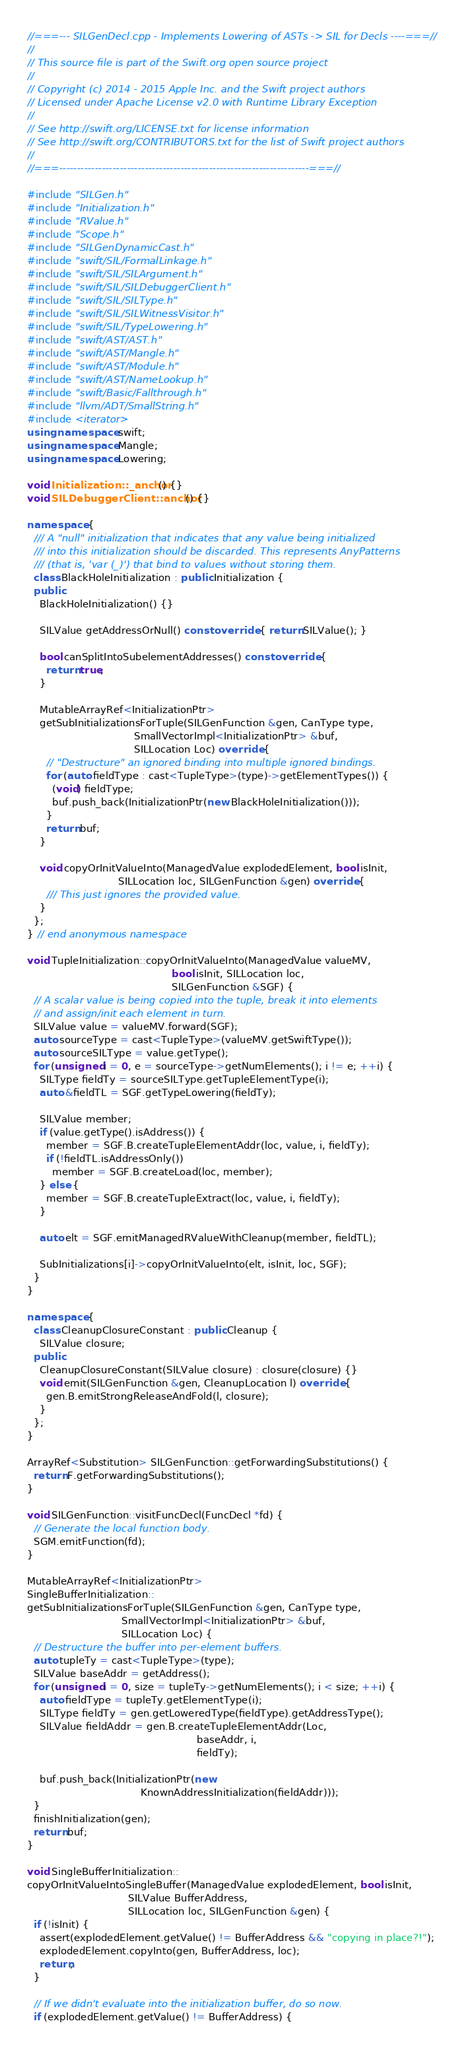<code> <loc_0><loc_0><loc_500><loc_500><_C++_>//===--- SILGenDecl.cpp - Implements Lowering of ASTs -> SIL for Decls ----===//
//
// This source file is part of the Swift.org open source project
//
// Copyright (c) 2014 - 2015 Apple Inc. and the Swift project authors
// Licensed under Apache License v2.0 with Runtime Library Exception
//
// See http://swift.org/LICENSE.txt for license information
// See http://swift.org/CONTRIBUTORS.txt for the list of Swift project authors
//
//===----------------------------------------------------------------------===//

#include "SILGen.h"
#include "Initialization.h"
#include "RValue.h"
#include "Scope.h"
#include "SILGenDynamicCast.h"
#include "swift/SIL/FormalLinkage.h"
#include "swift/SIL/SILArgument.h"
#include "swift/SIL/SILDebuggerClient.h"
#include "swift/SIL/SILType.h"
#include "swift/SIL/SILWitnessVisitor.h"
#include "swift/SIL/TypeLowering.h"
#include "swift/AST/AST.h"
#include "swift/AST/Mangle.h"
#include "swift/AST/Module.h"
#include "swift/AST/NameLookup.h"
#include "swift/Basic/Fallthrough.h"
#include "llvm/ADT/SmallString.h"
#include <iterator>
using namespace swift;
using namespace Mangle;
using namespace Lowering;

void Initialization::_anchor() {}
void SILDebuggerClient::anchor() {}

namespace {
  /// A "null" initialization that indicates that any value being initialized
  /// into this initialization should be discarded. This represents AnyPatterns
  /// (that is, 'var (_)') that bind to values without storing them.
  class BlackHoleInitialization : public Initialization {
  public:
    BlackHoleInitialization() {}

    SILValue getAddressOrNull() const override { return SILValue(); }

    bool canSplitIntoSubelementAddresses() const override {
      return true;
    }
    
    MutableArrayRef<InitializationPtr>
    getSubInitializationsForTuple(SILGenFunction &gen, CanType type,
                                  SmallVectorImpl<InitializationPtr> &buf,
                                  SILLocation Loc) override {
      // "Destructure" an ignored binding into multiple ignored bindings.
      for (auto fieldType : cast<TupleType>(type)->getElementTypes()) {
        (void) fieldType;
        buf.push_back(InitializationPtr(new BlackHoleInitialization()));
      }
      return buf;
    }

    void copyOrInitValueInto(ManagedValue explodedElement, bool isInit,
                             SILLocation loc, SILGenFunction &gen) override {
      /// This just ignores the provided value.
    }
  };
} // end anonymous namespace

void TupleInitialization::copyOrInitValueInto(ManagedValue valueMV,
                                              bool isInit, SILLocation loc,
                                              SILGenFunction &SGF) {
  // A scalar value is being copied into the tuple, break it into elements
  // and assign/init each element in turn.
  SILValue value = valueMV.forward(SGF);
  auto sourceType = cast<TupleType>(valueMV.getSwiftType());
  auto sourceSILType = value.getType();
  for (unsigned i = 0, e = sourceType->getNumElements(); i != e; ++i) {
    SILType fieldTy = sourceSILType.getTupleElementType(i);
    auto &fieldTL = SGF.getTypeLowering(fieldTy);
        
    SILValue member;
    if (value.getType().isAddress()) {
      member = SGF.B.createTupleElementAddr(loc, value, i, fieldTy);
      if (!fieldTL.isAddressOnly())
        member = SGF.B.createLoad(loc, member);
    } else {
      member = SGF.B.createTupleExtract(loc, value, i, fieldTy);
    }
        
    auto elt = SGF.emitManagedRValueWithCleanup(member, fieldTL);
        
    SubInitializations[i]->copyOrInitValueInto(elt, isInit, loc, SGF);
  }
}

namespace {
  class CleanupClosureConstant : public Cleanup {
    SILValue closure;
  public:
    CleanupClosureConstant(SILValue closure) : closure(closure) {}
    void emit(SILGenFunction &gen, CleanupLocation l) override {
      gen.B.emitStrongReleaseAndFold(l, closure);
    }
  };
}

ArrayRef<Substitution> SILGenFunction::getForwardingSubstitutions() {
  return F.getForwardingSubstitutions();
}

void SILGenFunction::visitFuncDecl(FuncDecl *fd) {
  // Generate the local function body.
  SGM.emitFunction(fd);
}

MutableArrayRef<InitializationPtr>
SingleBufferInitialization::
getSubInitializationsForTuple(SILGenFunction &gen, CanType type,
                              SmallVectorImpl<InitializationPtr> &buf,
                              SILLocation Loc) {
  // Destructure the buffer into per-element buffers.
  auto tupleTy = cast<TupleType>(type);
  SILValue baseAddr = getAddress();
  for (unsigned i = 0, size = tupleTy->getNumElements(); i < size; ++i) {
    auto fieldType = tupleTy.getElementType(i);
    SILType fieldTy = gen.getLoweredType(fieldType).getAddressType();
    SILValue fieldAddr = gen.B.createTupleElementAddr(Loc,
                                                      baseAddr, i,
                                                      fieldTy);
    
    buf.push_back(InitializationPtr(new
                                    KnownAddressInitialization(fieldAddr)));
  }
  finishInitialization(gen);
  return buf;
}

void SingleBufferInitialization::
copyOrInitValueIntoSingleBuffer(ManagedValue explodedElement, bool isInit,
                                SILValue BufferAddress,
                                SILLocation loc, SILGenFunction &gen) {
  if (!isInit) {
    assert(explodedElement.getValue() != BufferAddress && "copying in place?!");
    explodedElement.copyInto(gen, BufferAddress, loc);
    return;
  }
  
  // If we didn't evaluate into the initialization buffer, do so now.
  if (explodedElement.getValue() != BufferAddress) {</code> 